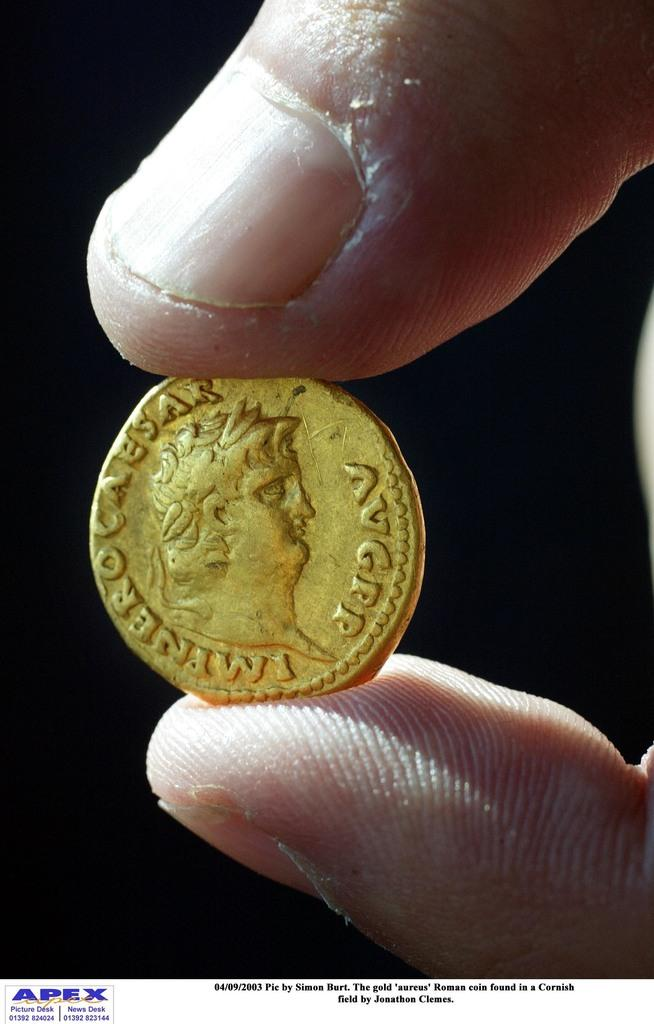<image>
Present a compact description of the photo's key features. Person holding a gold coin that has a face and the letters AVGPP on it. 